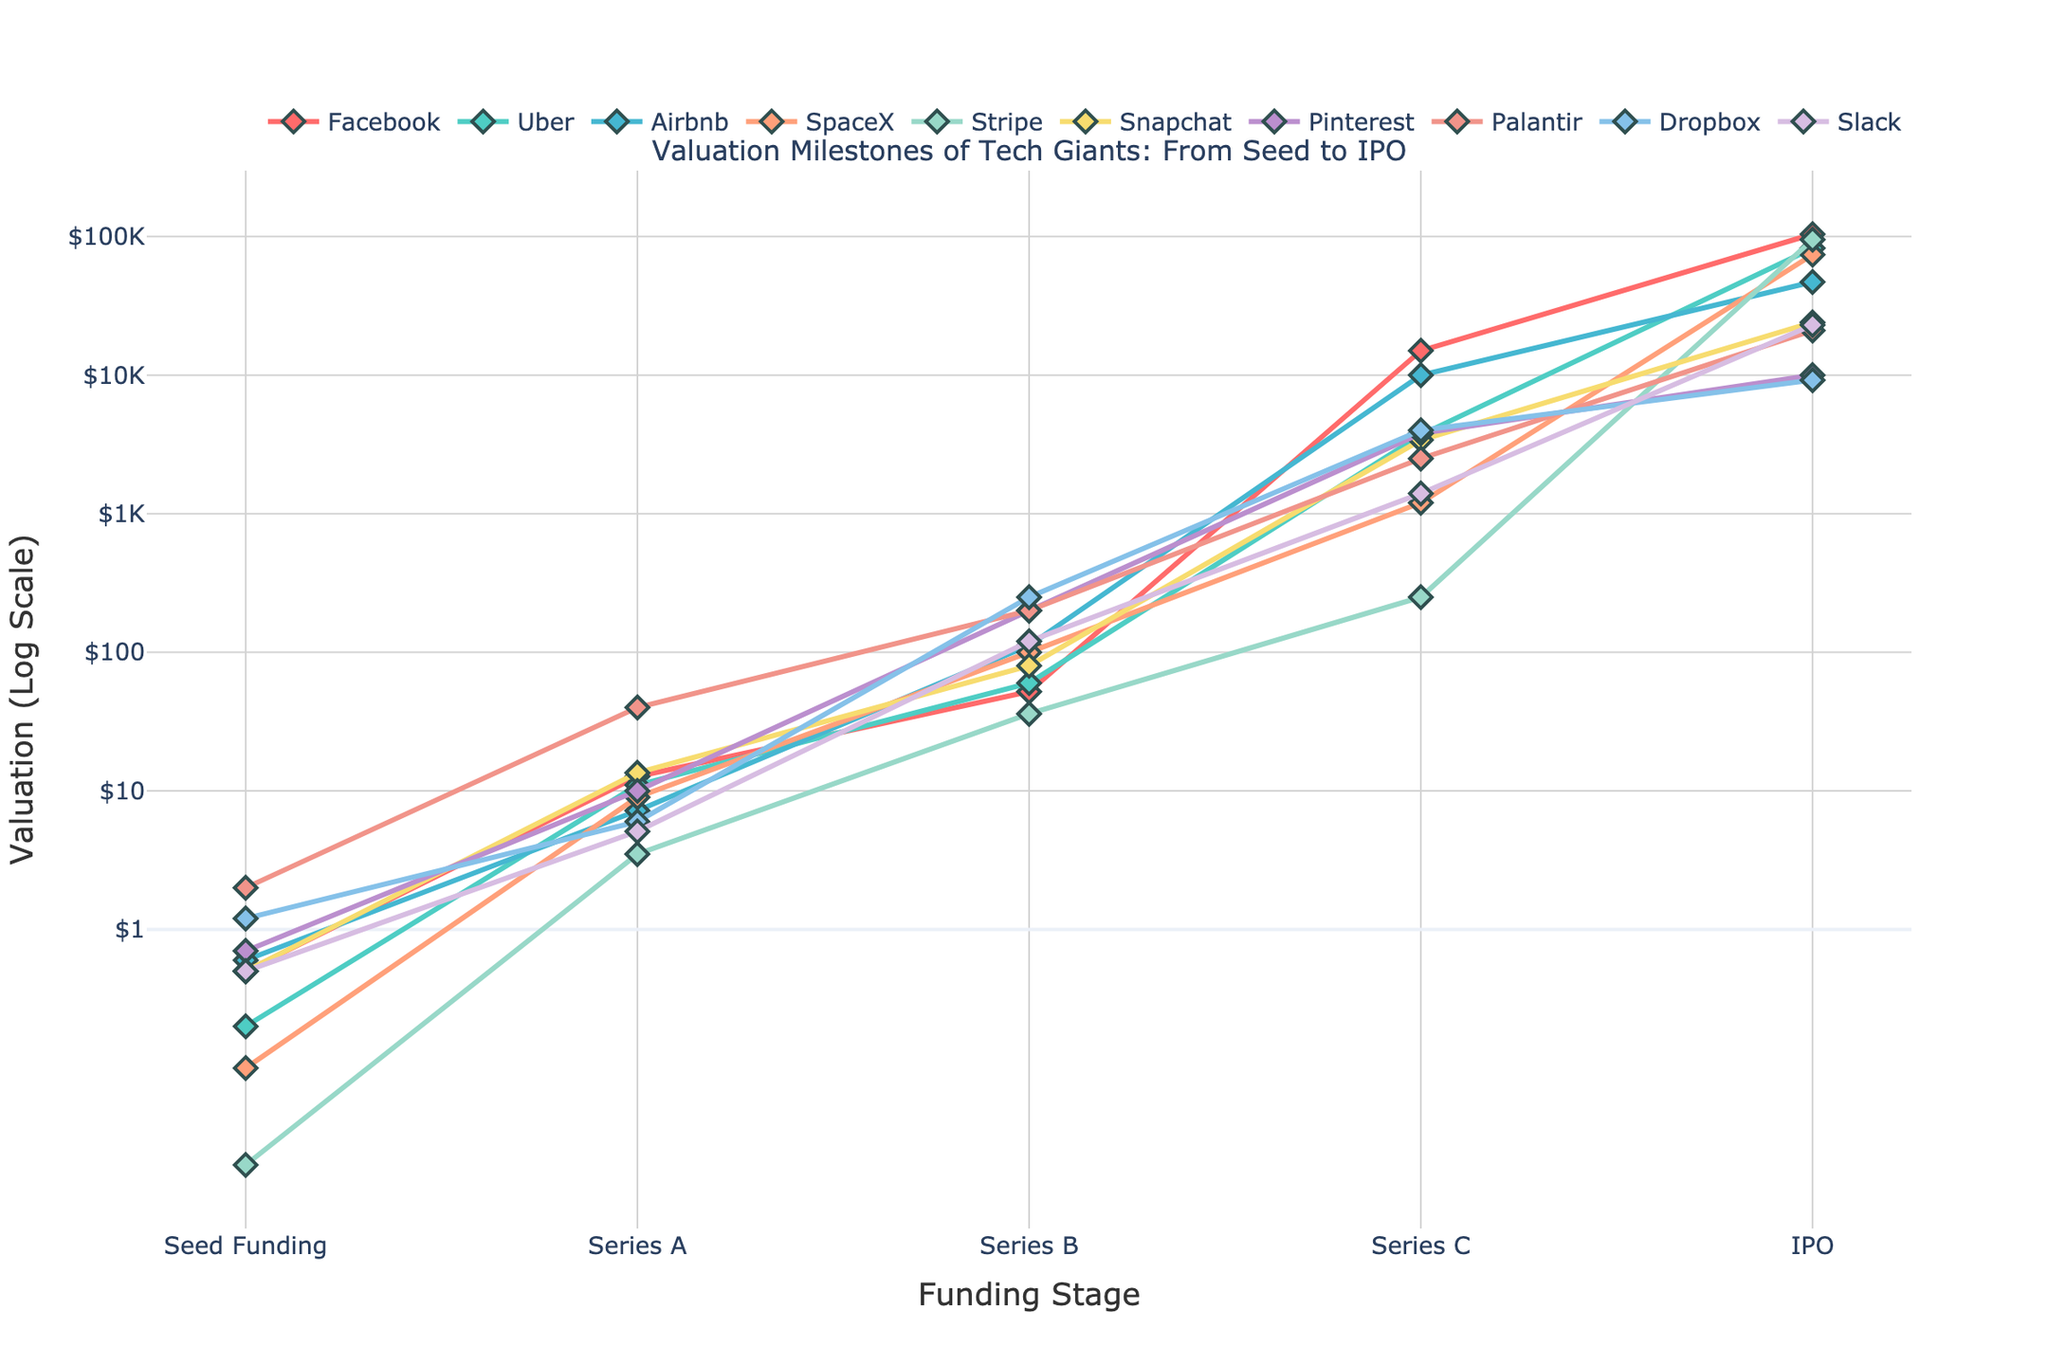Who reached the highest valuation at IPO? By looking at the plot, we can see that the line for Stripe ends at the highest point at the IPO stage.
Answer: Stripe Which company had the highest seed funding? Finding the highest point at the "Seed Funding" stage, we note that Palantir has the highest valuation.
Answer: Palantir What’s the difference in Series B valuation between Stripe and SpaceX? At Series B, Stripe's valuation is $36 million, and SpaceX's is $100 million. The difference is $100M - $36M = $64M.
Answer: $64M Which two companies have nearly identical Series A funding? By observing the lines at the Series A stage, Facebook and Snapchat have similar Series A valuations.
Answer: Facebook and Snapchat Compare Facebook and Uber's IPO valuations. Which is higher and by how much? Facebook's IPO valuation is $104B, and Uber's is $82.4B. The difference is $104B - $82.4B = $21.6B.
Answer: Facebook by $21.6B Which company had the steepest increase in valuation from Series C to IPO? By observing the plot, Facebook's line shows the steepest incline from Series C to IPO.
Answer: Facebook What is the average valuation of Series C across all companies? Summing the Series C valuations ($15000 + 3700 + 10000 + 1200 + 250 + 3400 + 3800 + 2500 + 4000 + 1400) and dividing by 10, we get (44500/10) = $4450M.
Answer: $4450M Which company has the highest valuation at Series B? Identifying the highest point at the Series B stage, we find that Dropbox's valuation is the highest at $250 million.
Answer: Dropbox Between Series A and Series B, which company had the largest increase in valuation? Calculating the difference for each company and comparing, Airbnb went from $7.2M to $112M, a difference of $104.8M, which is the largest.
Answer: Airbnb Compare the seed funding of Pinterest and Dropbox. Which is lower and by how much? Pinterest's seed funding is $0.7 million, and Dropbox's is $1.2 million. The difference is $1.2M - $0.7M = $0.5M.
Answer: Pinterest by $0.5M 